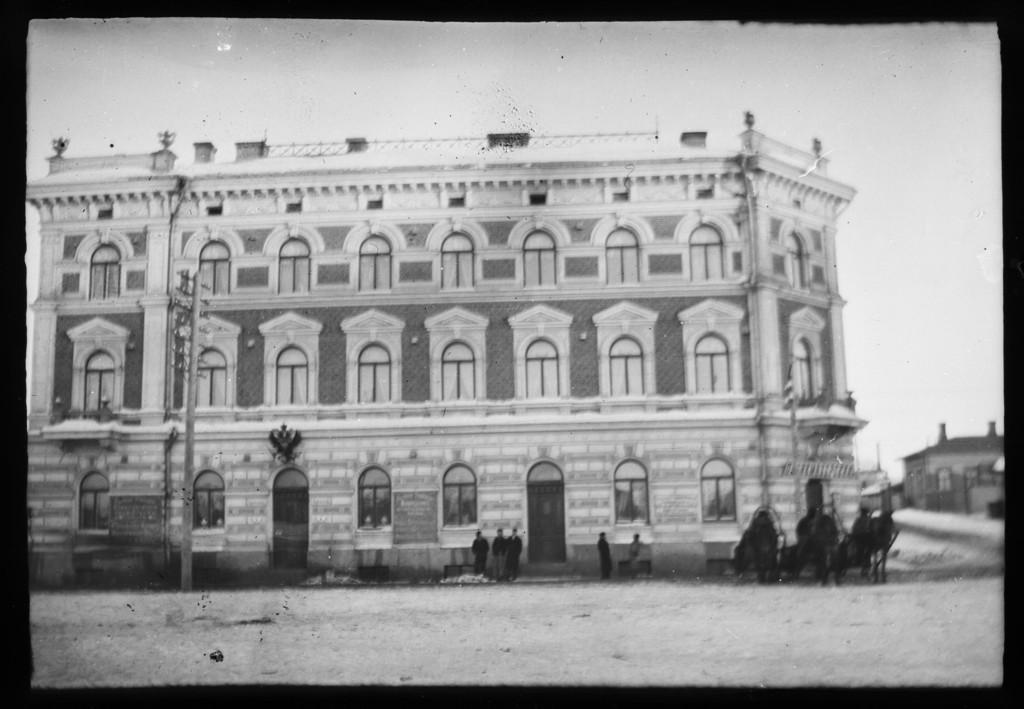What is depicted on the poster in the image? There is a poster with buildings in the image. What are the people in the image doing? The people are standing on the ground in the image. What is the purpose of the current pole in the image? The current pole is likely used for providing electricity to the area. What can be seen in the sky in the image? The sky is visible in the image. How many marbles are present in the image? There are no marbles visible in the image. What is the size of the pocket in the image? There is no pocket present in the image. 